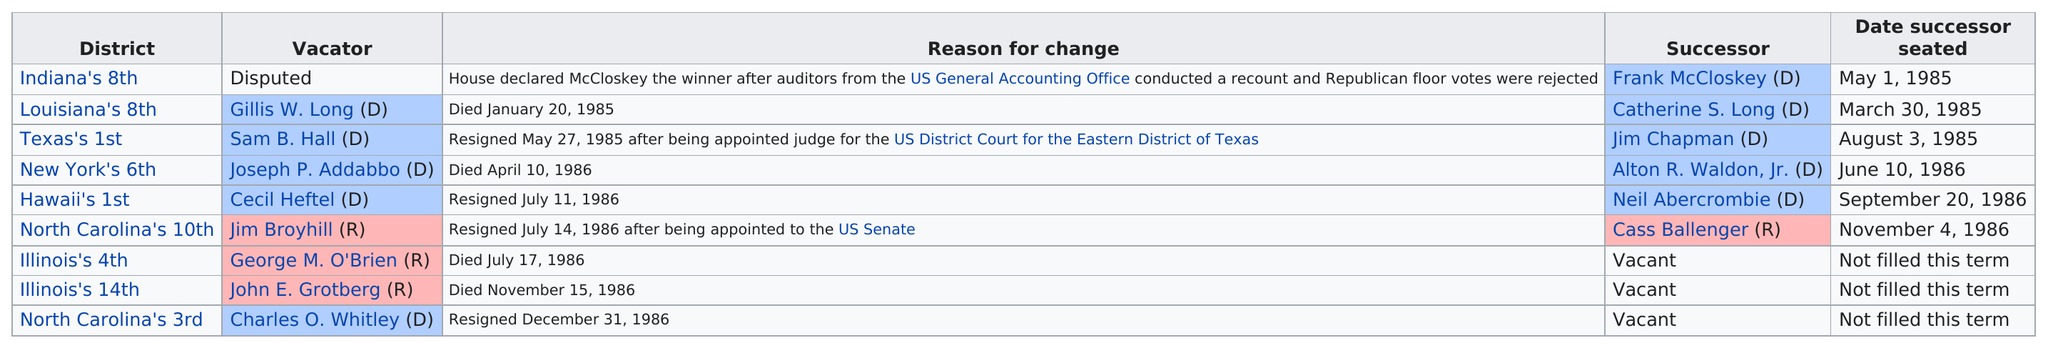Mention a couple of crucial points in this snapshot. Louisiana's 8th district was the first to have a successor seated. The number of times 'died' appears as the reason for change is 4. Catherine S. Long's previous representative was Gillis W. Long. On November 4, 1986, the last successor was seated. Out of the Democrats listed, two individuals have passed away. 